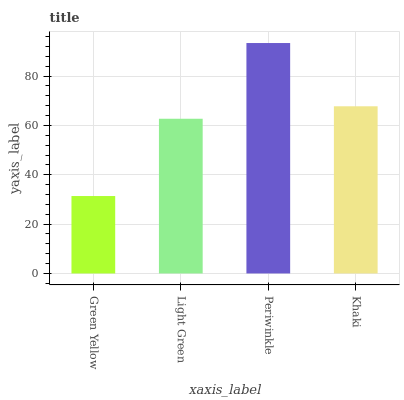Is Green Yellow the minimum?
Answer yes or no. Yes. Is Periwinkle the maximum?
Answer yes or no. Yes. Is Light Green the minimum?
Answer yes or no. No. Is Light Green the maximum?
Answer yes or no. No. Is Light Green greater than Green Yellow?
Answer yes or no. Yes. Is Green Yellow less than Light Green?
Answer yes or no. Yes. Is Green Yellow greater than Light Green?
Answer yes or no. No. Is Light Green less than Green Yellow?
Answer yes or no. No. Is Khaki the high median?
Answer yes or no. Yes. Is Light Green the low median?
Answer yes or no. Yes. Is Periwinkle the high median?
Answer yes or no. No. Is Green Yellow the low median?
Answer yes or no. No. 